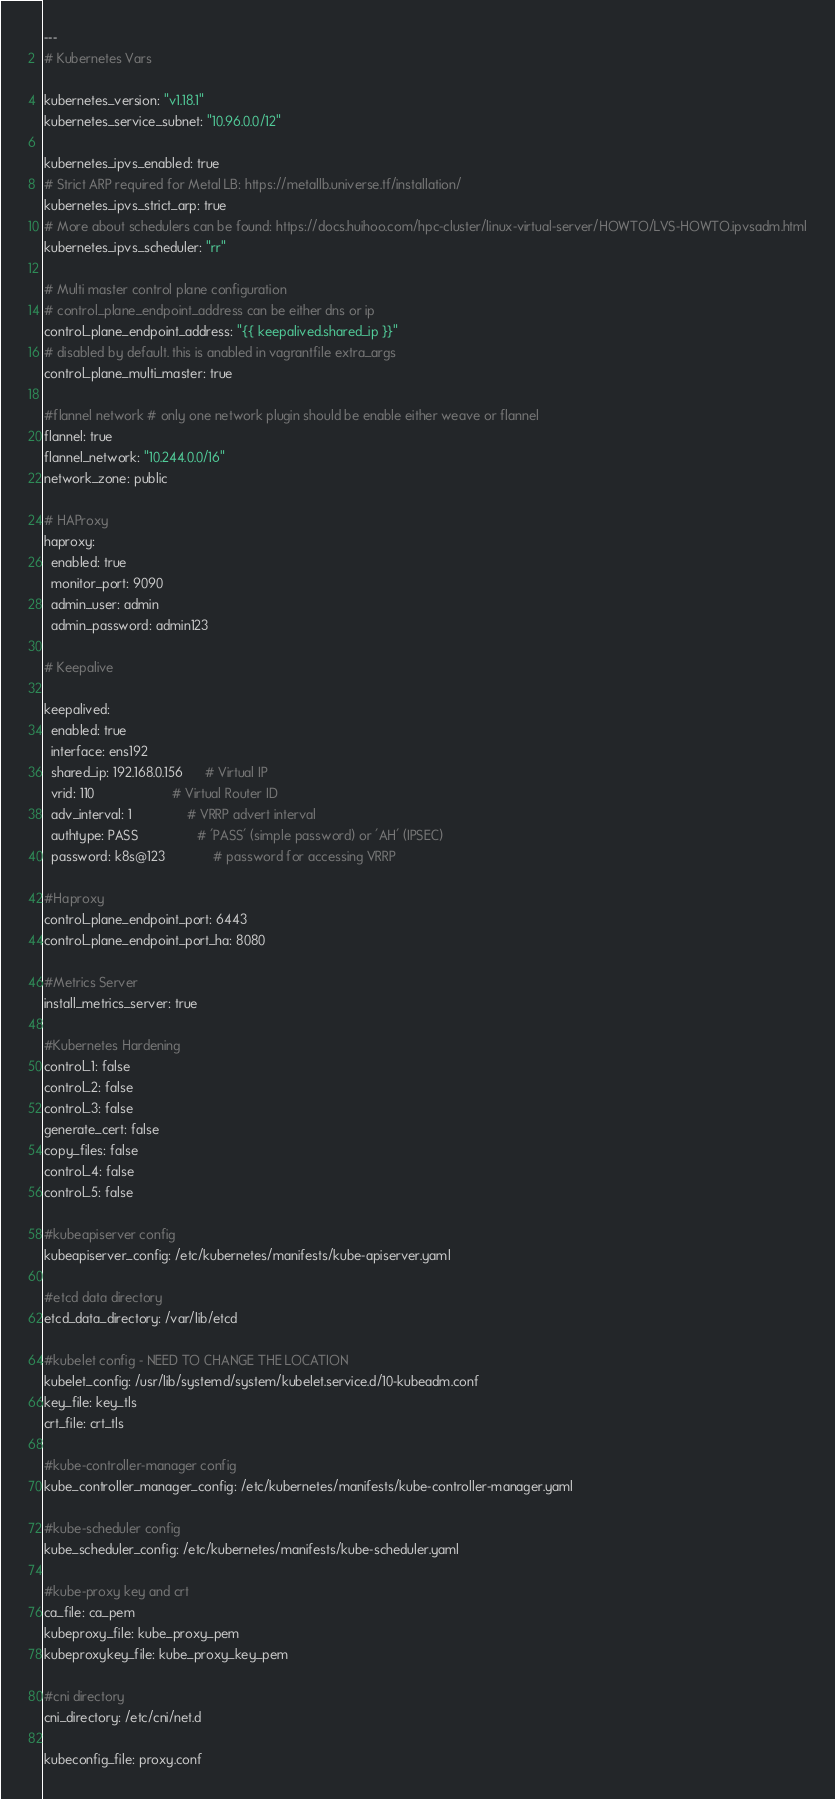Convert code to text. <code><loc_0><loc_0><loc_500><loc_500><_YAML_>---
# Kubernetes Vars

kubernetes_version: "v1.18.1"
kubernetes_service_subnet: "10.96.0.0/12"

kubernetes_ipvs_enabled: true
# Strict ARP required for Metal LB: https://metallb.universe.tf/installation/
kubernetes_ipvs_strict_arp: true
# More about schedulers can be found: https://docs.huihoo.com/hpc-cluster/linux-virtual-server/HOWTO/LVS-HOWTO.ipvsadm.html
kubernetes_ipvs_scheduler: "rr"

# Multi master control plane configuration
# control_plane_endpoint_address can be either dns or ip
control_plane_endpoint_address: "{{ keepalived.shared_ip }}"
# disabled by default. this is anabled in vagrantfile extra_args
control_plane_multi_master: true

#flannel network # only one network plugin should be enable either weave or flannel
flannel: true
flannel_network: "10.244.0.0/16"
network_zone: public

# HAProxy
haproxy:
  enabled: true
  monitor_port: 9090
  admin_user: admin
  admin_password: admin123

# Keepalive

keepalived:
  enabled: true
  interface: ens192
  shared_ip: 192.168.0.156      # Virtual IP
  vrid: 110                     # Virtual Router ID
  adv_interval: 1               # VRRP advert interval
  authtype: PASS                # 'PASS' (simple password) or 'AH' (IPSEC)
  password: k8s@123             # password for accessing VRRP

#Haproxy 
control_plane_endpoint_port: 6443
control_plane_endpoint_port_ha: 8080

#Metrics Server
install_metrics_server: true

#Kubernetes Hardening
control_1: false
control_2: false
control_3: false
generate_cert: false
copy_files: false
control_4: false
control_5: false

#kubeapiserver config
kubeapiserver_config: /etc/kubernetes/manifests/kube-apiserver.yaml

#etcd data directory
etcd_data_directory: /var/lib/etcd

#kubelet config - NEED TO CHANGE THE LOCATION
kubelet_config: /usr/lib/systemd/system/kubelet.service.d/10-kubeadm.conf
key_file: key_tls
crt_file: crt_tls

#kube-controller-manager config
kube_controller_manager_config: /etc/kubernetes/manifests/kube-controller-manager.yaml

#kube-scheduler config
kube_scheduler_config: /etc/kubernetes/manifests/kube-scheduler.yaml

#kube-proxy key and crt
ca_file: ca_pem
kubeproxy_file: kube_proxy_pem
kubeproxykey_file: kube_proxy_key_pem

#cni directory
cni_directory: /etc/cni/net.d

kubeconfig_file: proxy.conf</code> 